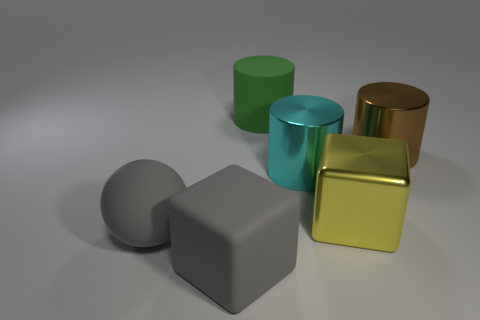Add 1 large objects. How many objects exist? 7 Subtract all spheres. How many objects are left? 5 Subtract all tiny yellow shiny cylinders. Subtract all large cyan cylinders. How many objects are left? 5 Add 1 yellow objects. How many yellow objects are left? 2 Add 6 large metal things. How many large metal things exist? 9 Subtract 1 gray cubes. How many objects are left? 5 